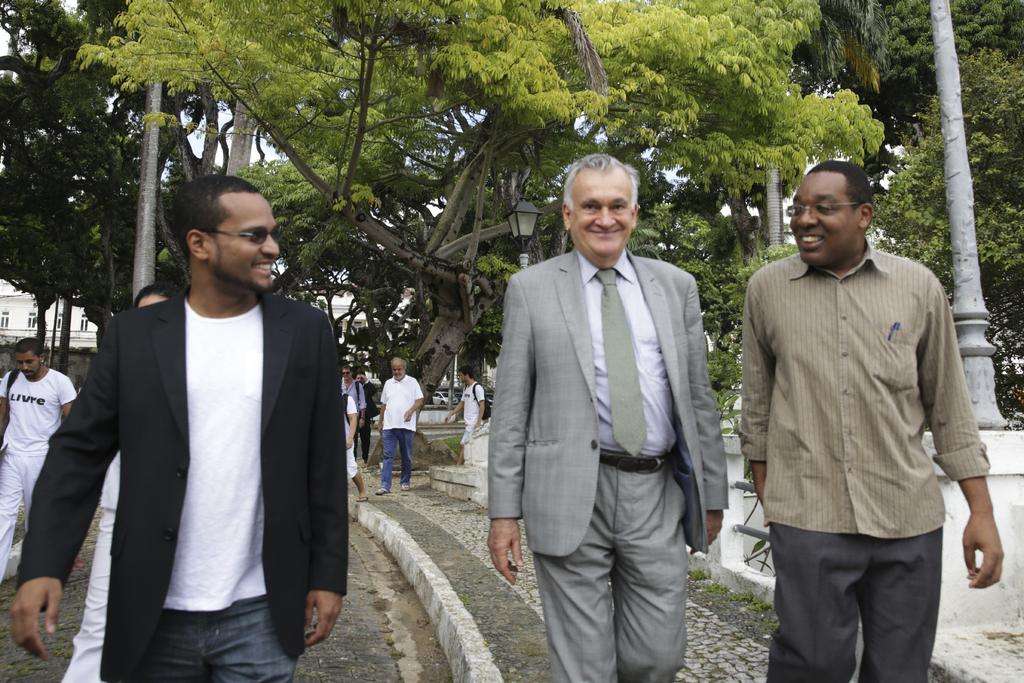What are the people in the image doing? The people in the image are walking. How are the people in the image feeling? The people are smiling, which suggests they are happy or enjoying themselves. Can you describe the background of the image? In the background of the image, there are more people walking, trees, poles, a building, and the sky. What advice is the flag giving to the people in the image? There is no flag present in the image, so it cannot provide any advice. 